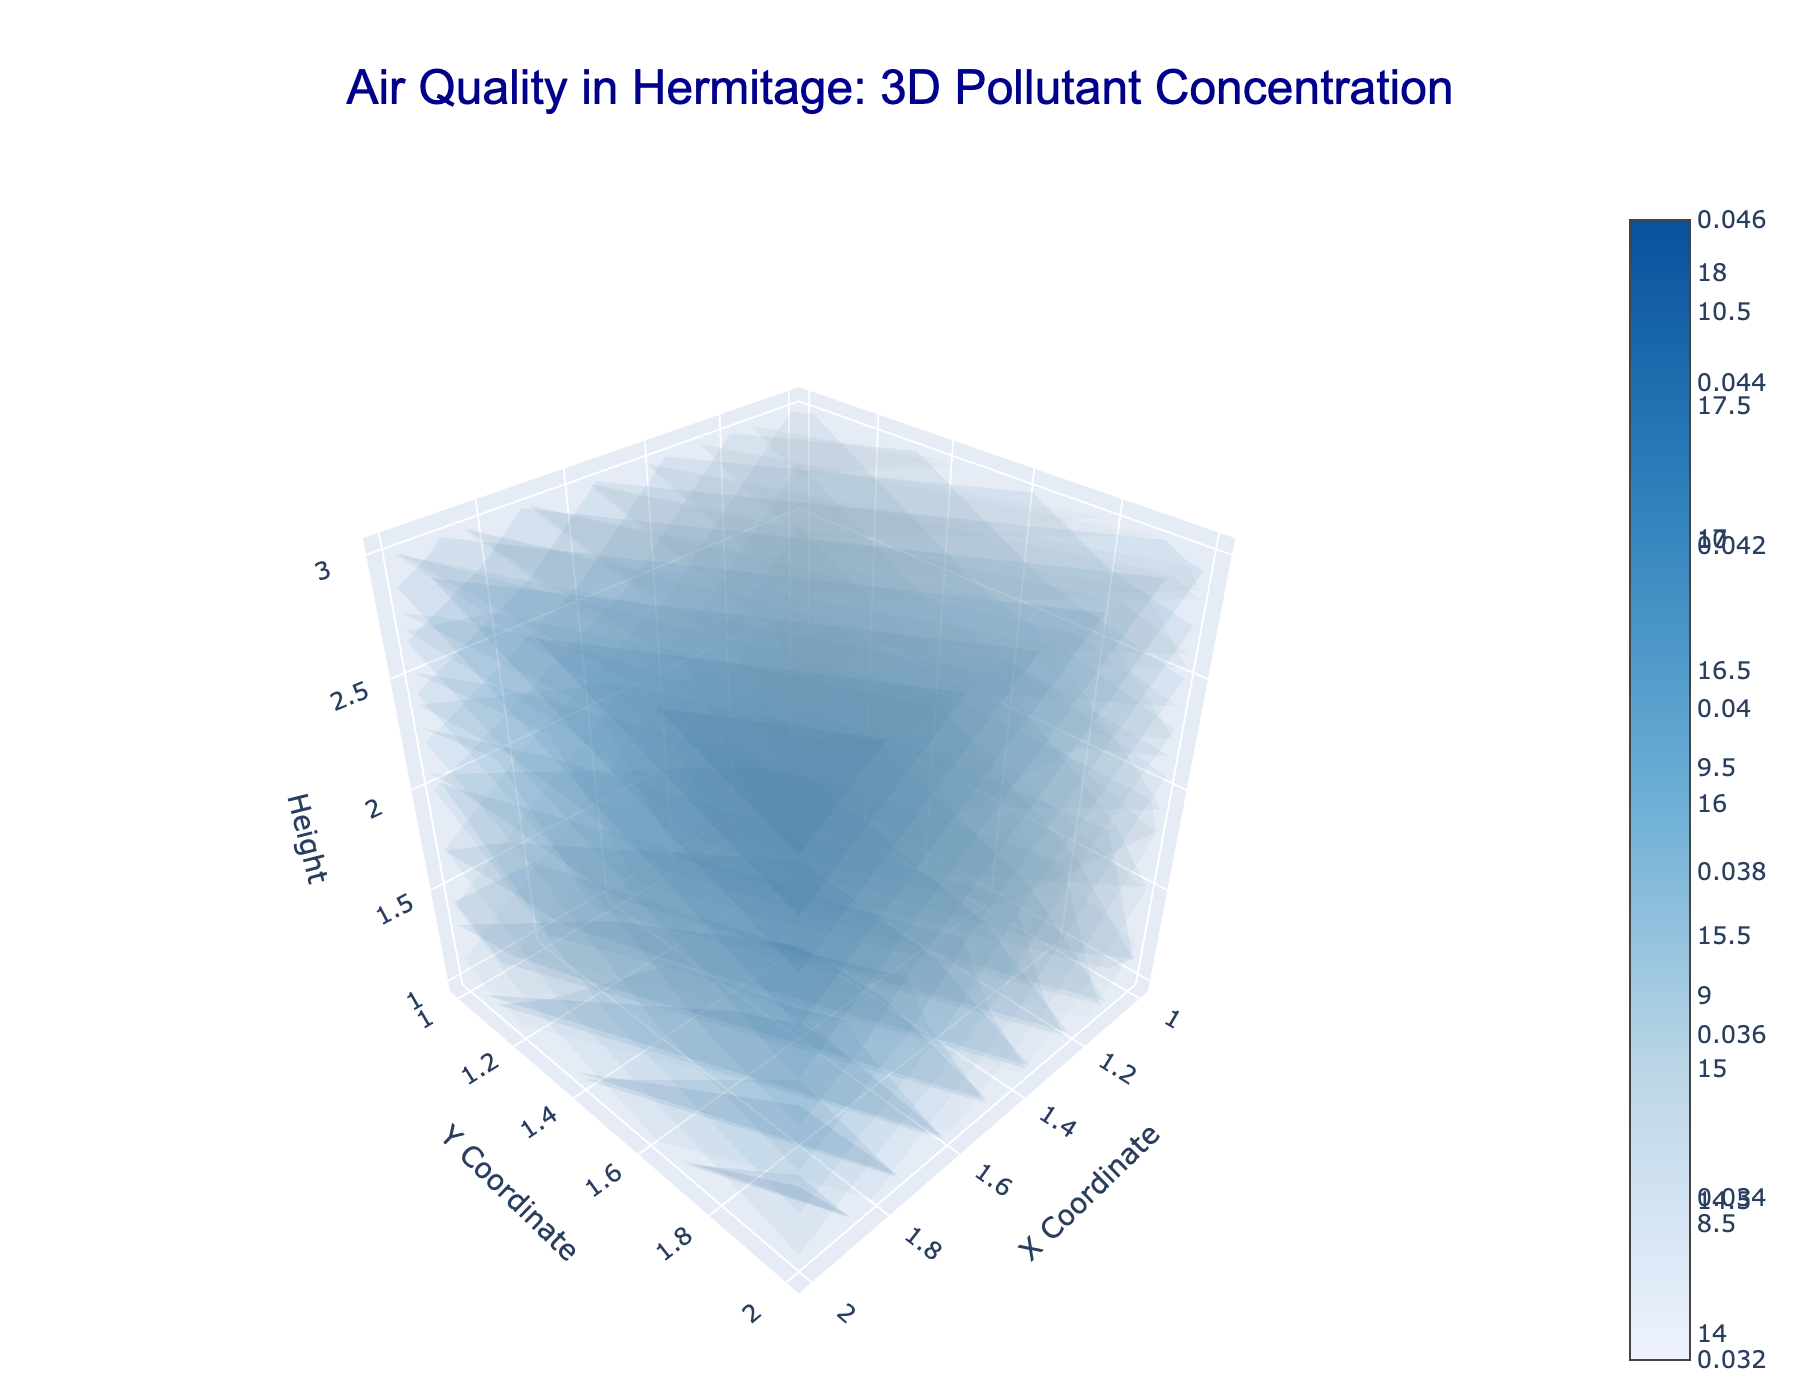What is the title of the plot? The title is located at the top of the chart. It describes the main subject of the visualization, which is air quality measurements in Hermitage.
Answer: Air Quality in Hermitage: 3D Pollutant Concentration Which pollutants are visualized in this plot? By looking at the legend or examining the labels on each part of the visualization, we can see which pollutants are represented in the figure.
Answer: PM2.5, Ozone, NO2 What are the axis labels and their titles? The axis labels are located at the side of each axis. They indicate what each axis represents in the 3D space. In this plot, they're labeled as X Coordinate, Y Coordinate, and Height.
Answer: X Coordinate, Y Coordinate, Height Which pollutant has the highest maximum concentration value? By examining the color scale and isosurfaces in the volume plot, we can identify the pollutant with the highest isomax value.
Answer: Ozone For the pollutant PM2.5, at which coordinates is the highest concentration observed? By visually inspecting the intersecting volume areas with the highest color intensity for PM2.5, we can locate the coordinates with the highest value.
Answer: (2, 2, 1) How does the concentration of Ozone at the highest height (z=3) compare to its concentration at ground level (z=1)? We need to compare the color intensities or values at the height of 3 and at the height of 1 for Ozone. The higher intensity indicates a higher concentration.
Answer: Higher at z=3 What is the concentration of NO2 at the coordinate (1, 1, 1)? By finding the specific coordinate in the volume plot and noting the corresponding value, we can determine the concentration.
Answer: 9.1 Which pollutant shows the most variation in concentrations across different heights? By examining the changes in color intensities and isosurfaces along the height (z-axis) for each pollutant, we can determine which has the biggest changes.
Answer: Ozone What is the average concentration of PM2.5 across all coordinates? To find this, we sum the concentration values for PM2.5 from all coordinates and then divide by the number of data points. There are 12 values to sum and divide.
Answer: About 15.4 (computed as (15.2 + 14.8 + 13.9 + 16.1 + 15.7 + 14.5 + 17.3 + 16.9 + 15.8 + 18.2 + 17.6 + 16.4) / 12) Between the pollutants PM2.5 and NO2, which one has a higher minimum concentration value? By comparing the lowest concentration values for PM2.5 and NO2, we can determine which has a higher minimum value.
Answer: NO2 